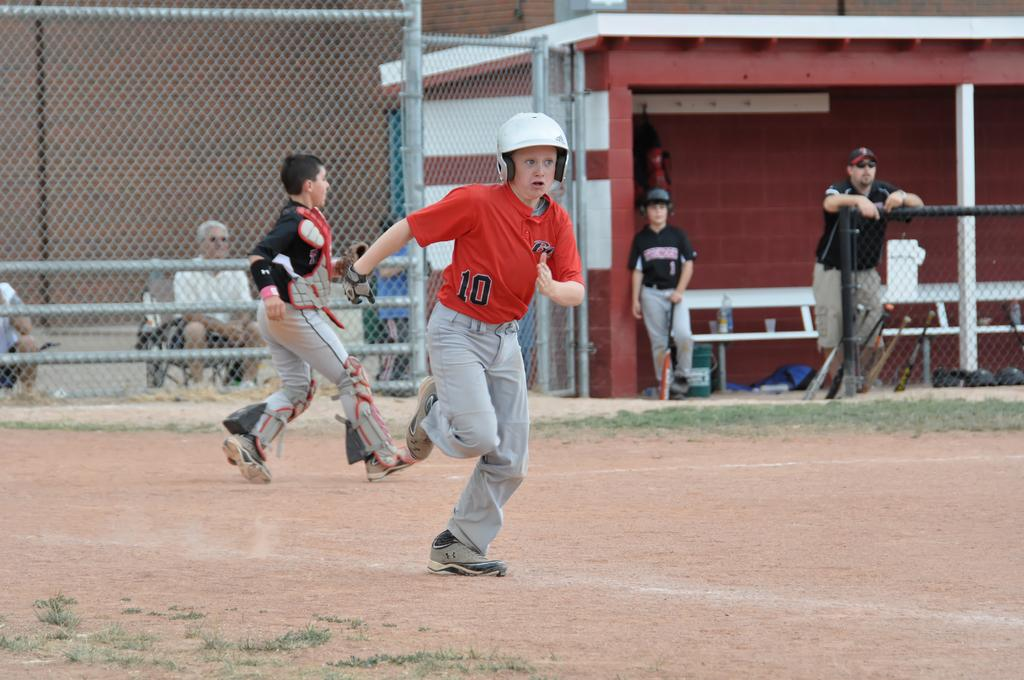How many people are in the image? There is a group of people in the image. What are the people in the image doing? Some people are sitting, some are standing, and some are running. What can be seen in the background of the image? There is a fence and a boy in the background of the image. What is the boy holding in the image? The boy is holding a bat. What type of scent can be smelled coming from the faucet in the image? There is no faucet present in the image, so it is not possible to determine any scent. 